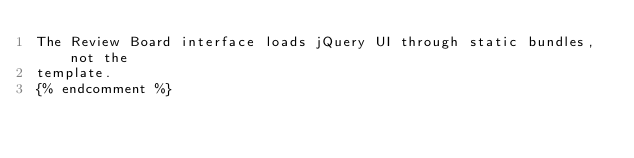Convert code to text. <code><loc_0><loc_0><loc_500><loc_500><_HTML_>The Review Board interface loads jQuery UI through static bundles, not the
template.
{% endcomment %}
</code> 